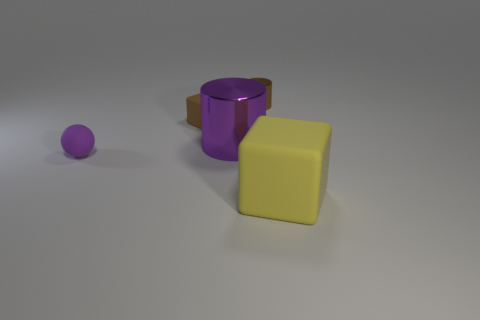Are there any shadows visible in the image? Yes, each object casts a shadow on the surface, suggesting a light source located above and to the left as inferred from the direction of the shadows. 